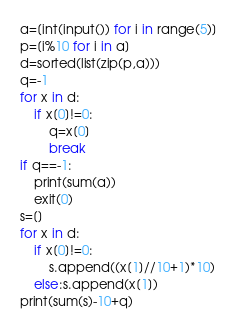Convert code to text. <code><loc_0><loc_0><loc_500><loc_500><_Python_>a=[int(input()) for i in range(5)]
p=[i%10 for i in a]
d=sorted(list(zip(p,a)))
q=-1
for x in d:
    if x[0]!=0:
        q=x[0]
        break
if q==-1:
    print(sum(a))
    exit(0)
s=[]
for x in d:
    if x[0]!=0:
        s.append((x[1]//10+1)*10)
    else:s.append(x[1])
print(sum(s)-10+q)</code> 